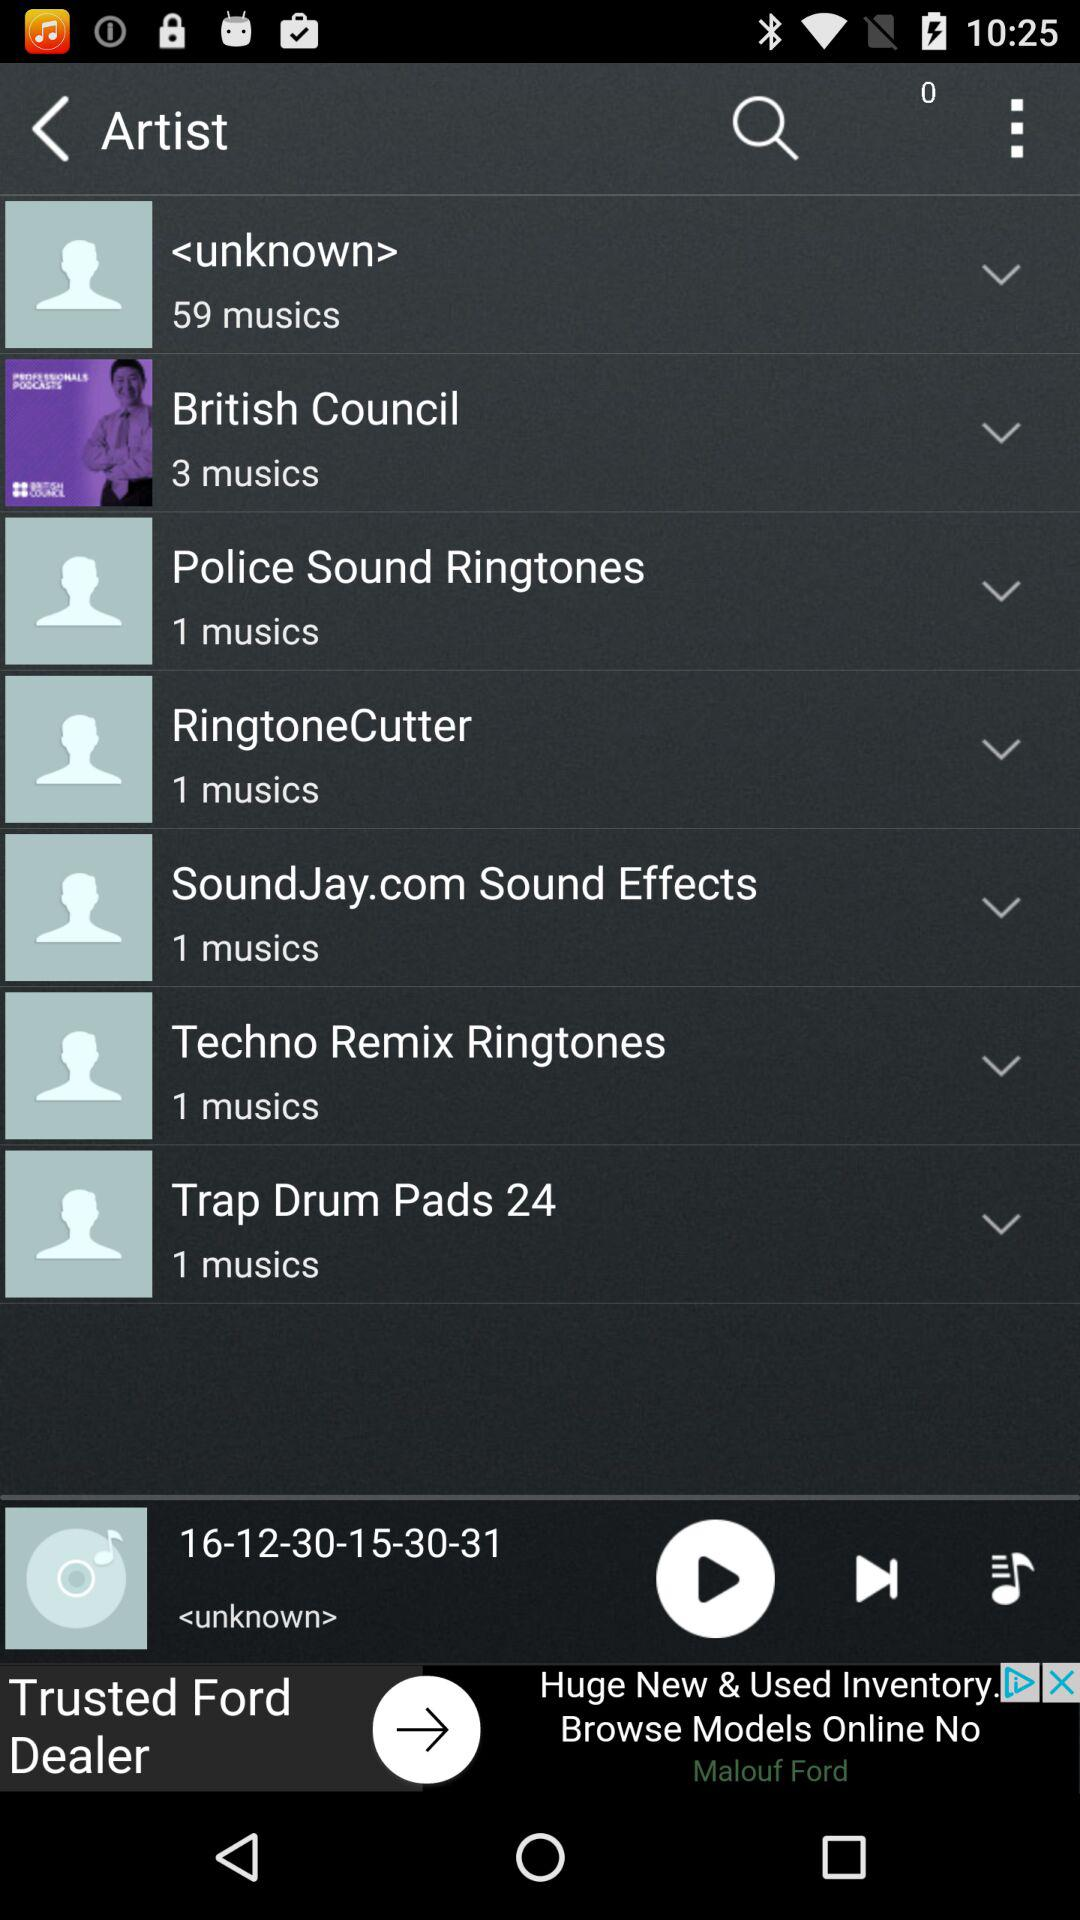How many more musics does <unknown> have than British Council?
Answer the question using a single word or phrase. 56 